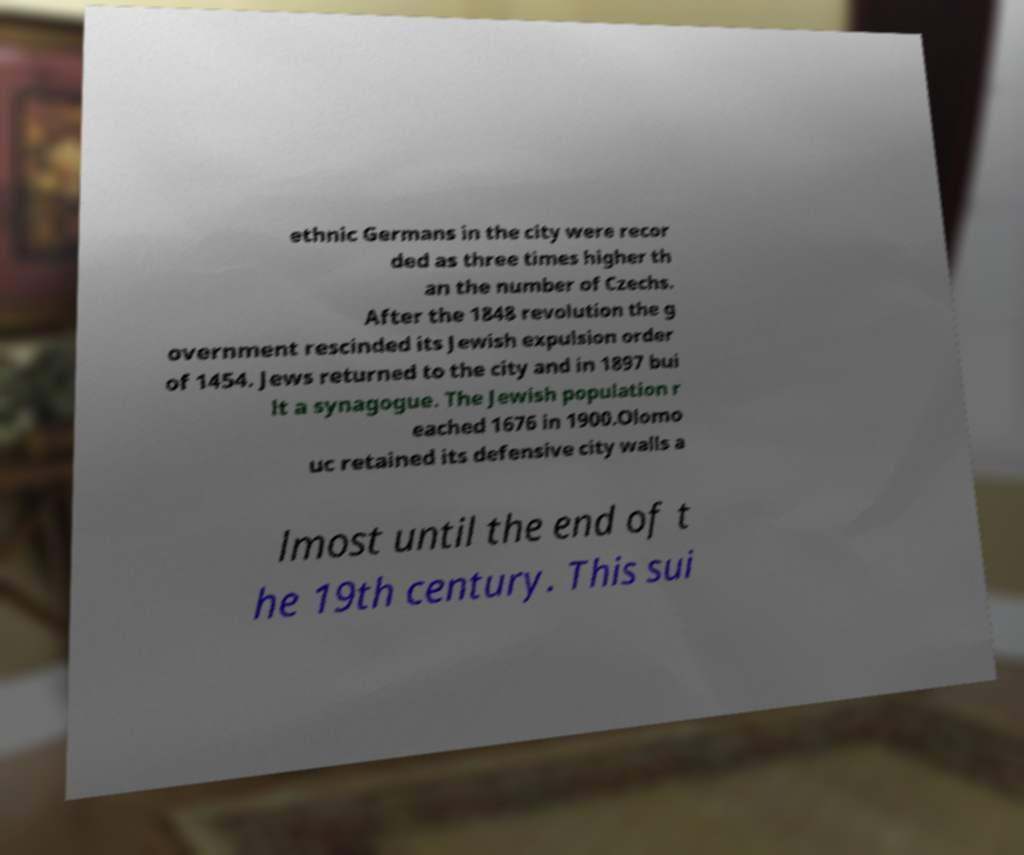I need the written content from this picture converted into text. Can you do that? ethnic Germans in the city were recor ded as three times higher th an the number of Czechs. After the 1848 revolution the g overnment rescinded its Jewish expulsion order of 1454. Jews returned to the city and in 1897 bui lt a synagogue. The Jewish population r eached 1676 in 1900.Olomo uc retained its defensive city walls a lmost until the end of t he 19th century. This sui 